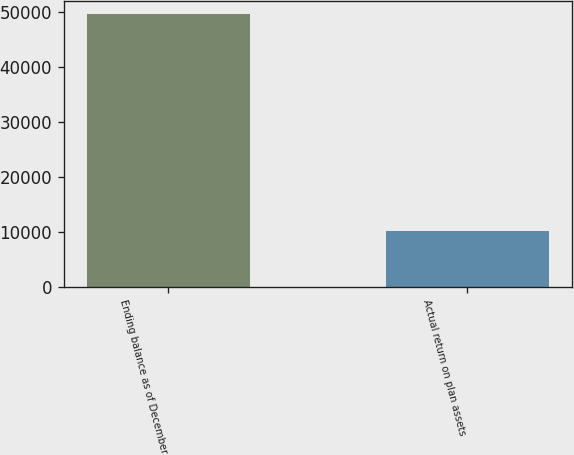Convert chart to OTSL. <chart><loc_0><loc_0><loc_500><loc_500><bar_chart><fcel>Ending balance as of December<fcel>Actual return on plan assets<nl><fcel>49556<fcel>10249<nl></chart> 